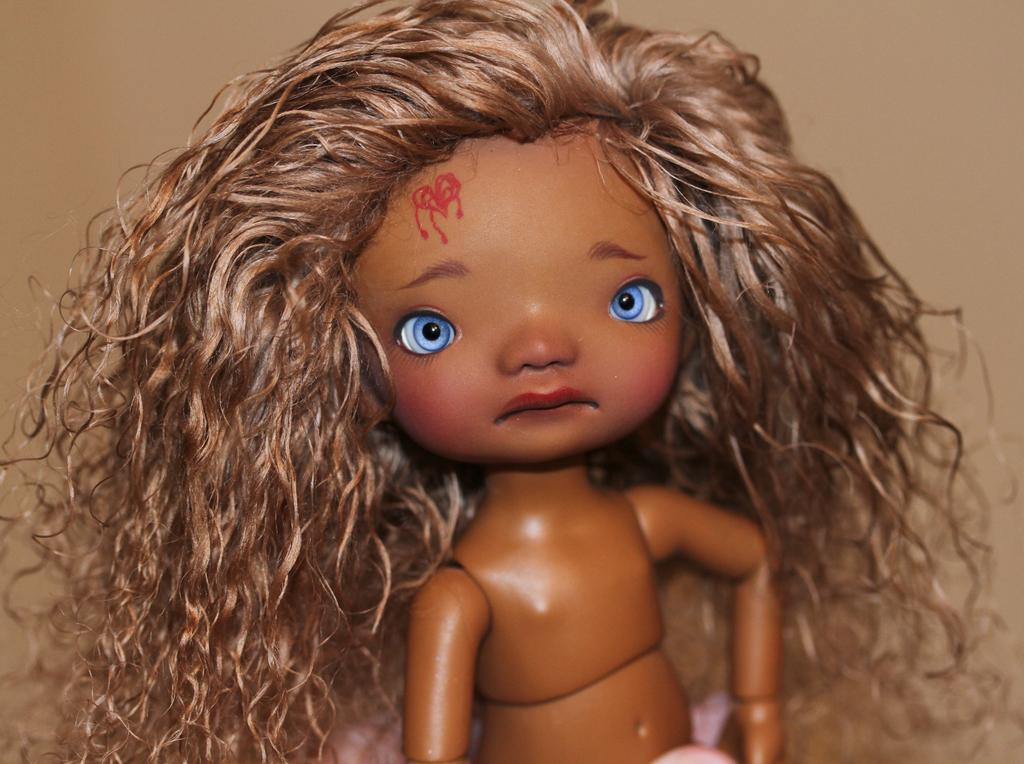What is the main subject of the image? There is a doll in the image. Where is the tub located in the image? There is no tub present in the image. How many cents are visible in the image? There are no cents present in the image. 